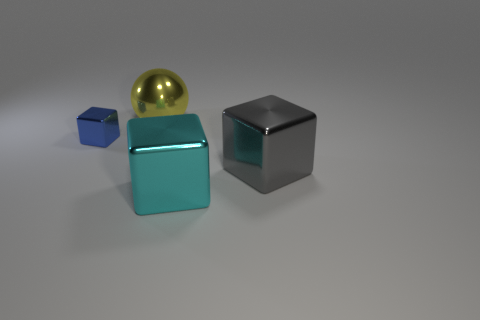Add 3 large metal blocks. How many objects exist? 7 Subtract all blocks. How many objects are left? 1 Add 1 big cyan metal things. How many big cyan metal things are left? 2 Add 4 tiny green objects. How many tiny green objects exist? 4 Subtract 0 brown cubes. How many objects are left? 4 Subtract all big red metallic balls. Subtract all big metallic cubes. How many objects are left? 2 